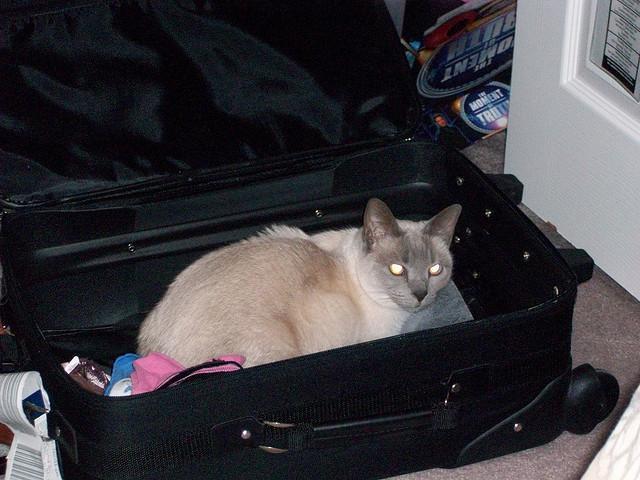How many cats can you see?
Give a very brief answer. 1. 